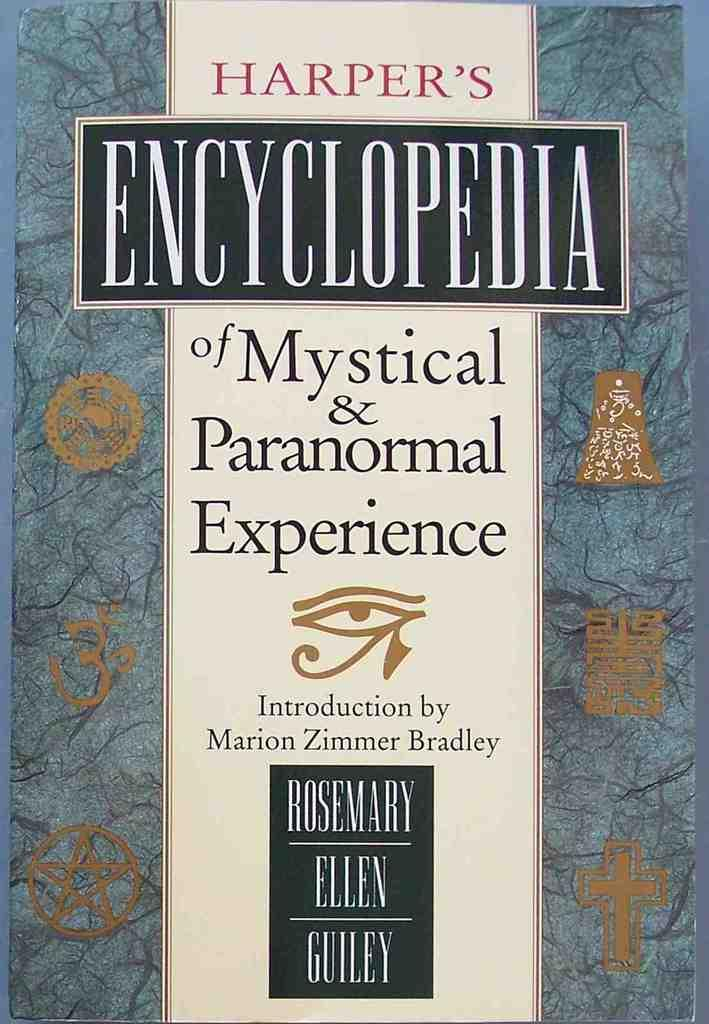<image>
Share a concise interpretation of the image provided. The book Harper's Encyclopedia of Mystical & Paranormal Experience was written by Rosemary Ellen Guiley. 